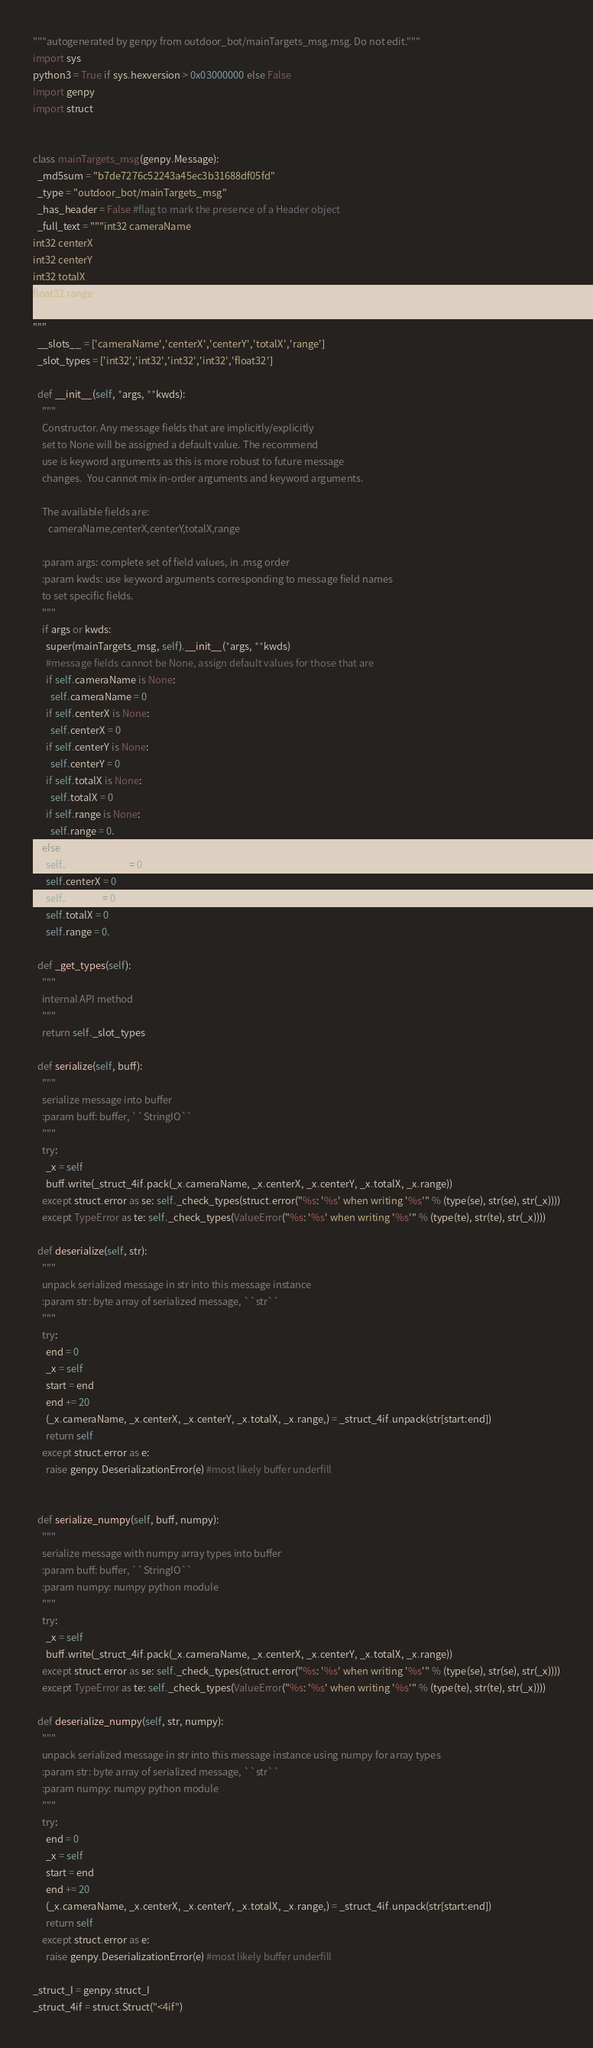Convert code to text. <code><loc_0><loc_0><loc_500><loc_500><_Python_>"""autogenerated by genpy from outdoor_bot/mainTargets_msg.msg. Do not edit."""
import sys
python3 = True if sys.hexversion > 0x03000000 else False
import genpy
import struct


class mainTargets_msg(genpy.Message):
  _md5sum = "b7de7276c52243a45ec3b31688df05fd"
  _type = "outdoor_bot/mainTargets_msg"
  _has_header = False #flag to mark the presence of a Header object
  _full_text = """int32 cameraName
int32 centerX
int32 centerY
int32 totalX
float32 range

"""
  __slots__ = ['cameraName','centerX','centerY','totalX','range']
  _slot_types = ['int32','int32','int32','int32','float32']

  def __init__(self, *args, **kwds):
    """
    Constructor. Any message fields that are implicitly/explicitly
    set to None will be assigned a default value. The recommend
    use is keyword arguments as this is more robust to future message
    changes.  You cannot mix in-order arguments and keyword arguments.

    The available fields are:
       cameraName,centerX,centerY,totalX,range

    :param args: complete set of field values, in .msg order
    :param kwds: use keyword arguments corresponding to message field names
    to set specific fields.
    """
    if args or kwds:
      super(mainTargets_msg, self).__init__(*args, **kwds)
      #message fields cannot be None, assign default values for those that are
      if self.cameraName is None:
        self.cameraName = 0
      if self.centerX is None:
        self.centerX = 0
      if self.centerY is None:
        self.centerY = 0
      if self.totalX is None:
        self.totalX = 0
      if self.range is None:
        self.range = 0.
    else:
      self.cameraName = 0
      self.centerX = 0
      self.centerY = 0
      self.totalX = 0
      self.range = 0.

  def _get_types(self):
    """
    internal API method
    """
    return self._slot_types

  def serialize(self, buff):
    """
    serialize message into buffer
    :param buff: buffer, ``StringIO``
    """
    try:
      _x = self
      buff.write(_struct_4if.pack(_x.cameraName, _x.centerX, _x.centerY, _x.totalX, _x.range))
    except struct.error as se: self._check_types(struct.error("%s: '%s' when writing '%s'" % (type(se), str(se), str(_x))))
    except TypeError as te: self._check_types(ValueError("%s: '%s' when writing '%s'" % (type(te), str(te), str(_x))))

  def deserialize(self, str):
    """
    unpack serialized message in str into this message instance
    :param str: byte array of serialized message, ``str``
    """
    try:
      end = 0
      _x = self
      start = end
      end += 20
      (_x.cameraName, _x.centerX, _x.centerY, _x.totalX, _x.range,) = _struct_4if.unpack(str[start:end])
      return self
    except struct.error as e:
      raise genpy.DeserializationError(e) #most likely buffer underfill


  def serialize_numpy(self, buff, numpy):
    """
    serialize message with numpy array types into buffer
    :param buff: buffer, ``StringIO``
    :param numpy: numpy python module
    """
    try:
      _x = self
      buff.write(_struct_4if.pack(_x.cameraName, _x.centerX, _x.centerY, _x.totalX, _x.range))
    except struct.error as se: self._check_types(struct.error("%s: '%s' when writing '%s'" % (type(se), str(se), str(_x))))
    except TypeError as te: self._check_types(ValueError("%s: '%s' when writing '%s'" % (type(te), str(te), str(_x))))

  def deserialize_numpy(self, str, numpy):
    """
    unpack serialized message in str into this message instance using numpy for array types
    :param str: byte array of serialized message, ``str``
    :param numpy: numpy python module
    """
    try:
      end = 0
      _x = self
      start = end
      end += 20
      (_x.cameraName, _x.centerX, _x.centerY, _x.totalX, _x.range,) = _struct_4if.unpack(str[start:end])
      return self
    except struct.error as e:
      raise genpy.DeserializationError(e) #most likely buffer underfill

_struct_I = genpy.struct_I
_struct_4if = struct.Struct("<4if")
</code> 